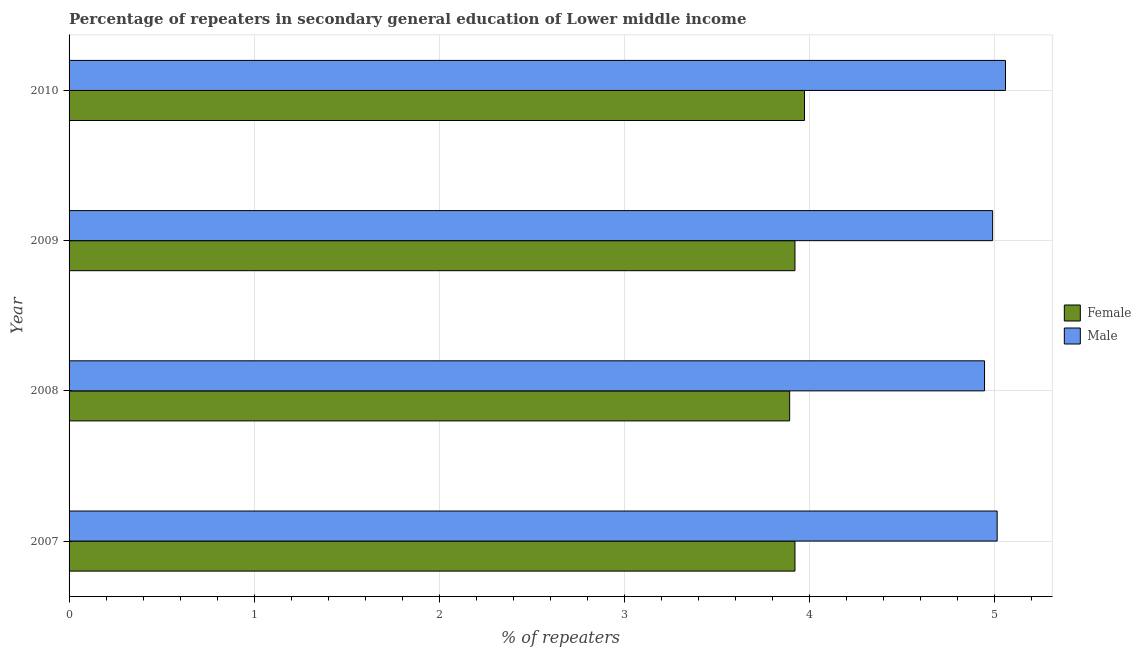Are the number of bars per tick equal to the number of legend labels?
Your answer should be very brief. Yes. How many bars are there on the 3rd tick from the bottom?
Offer a very short reply. 2. What is the percentage of male repeaters in 2007?
Give a very brief answer. 5.01. Across all years, what is the maximum percentage of female repeaters?
Give a very brief answer. 3.97. Across all years, what is the minimum percentage of female repeaters?
Give a very brief answer. 3.89. In which year was the percentage of female repeaters maximum?
Your answer should be compact. 2010. In which year was the percentage of male repeaters minimum?
Your answer should be very brief. 2008. What is the total percentage of male repeaters in the graph?
Offer a terse response. 20. What is the difference between the percentage of male repeaters in 2008 and that in 2010?
Your answer should be compact. -0.11. What is the difference between the percentage of female repeaters in 2008 and the percentage of male repeaters in 2007?
Provide a short and direct response. -1.12. What is the average percentage of female repeaters per year?
Keep it short and to the point. 3.93. In the year 2010, what is the difference between the percentage of female repeaters and percentage of male repeaters?
Offer a very short reply. -1.09. Is the difference between the percentage of male repeaters in 2007 and 2009 greater than the difference between the percentage of female repeaters in 2007 and 2009?
Your answer should be compact. Yes. What is the difference between the highest and the second highest percentage of female repeaters?
Provide a succinct answer. 0.05. What is the difference between the highest and the lowest percentage of male repeaters?
Your answer should be compact. 0.11. What does the 2nd bar from the top in 2010 represents?
Your response must be concise. Female. What does the 1st bar from the bottom in 2008 represents?
Your response must be concise. Female. Are all the bars in the graph horizontal?
Offer a very short reply. Yes. How many years are there in the graph?
Offer a terse response. 4. Does the graph contain grids?
Provide a succinct answer. Yes. Where does the legend appear in the graph?
Provide a short and direct response. Center right. What is the title of the graph?
Keep it short and to the point. Percentage of repeaters in secondary general education of Lower middle income. What is the label or title of the X-axis?
Your response must be concise. % of repeaters. What is the label or title of the Y-axis?
Offer a very short reply. Year. What is the % of repeaters of Female in 2007?
Your answer should be very brief. 3.92. What is the % of repeaters of Male in 2007?
Your response must be concise. 5.01. What is the % of repeaters of Female in 2008?
Offer a very short reply. 3.89. What is the % of repeaters in Male in 2008?
Offer a terse response. 4.94. What is the % of repeaters in Female in 2009?
Keep it short and to the point. 3.92. What is the % of repeaters of Male in 2009?
Provide a short and direct response. 4.99. What is the % of repeaters of Female in 2010?
Keep it short and to the point. 3.97. What is the % of repeaters in Male in 2010?
Ensure brevity in your answer.  5.06. Across all years, what is the maximum % of repeaters of Female?
Your answer should be compact. 3.97. Across all years, what is the maximum % of repeaters in Male?
Make the answer very short. 5.06. Across all years, what is the minimum % of repeaters in Female?
Your response must be concise. 3.89. Across all years, what is the minimum % of repeaters in Male?
Your answer should be very brief. 4.94. What is the total % of repeaters of Female in the graph?
Keep it short and to the point. 15.71. What is the total % of repeaters of Male in the graph?
Ensure brevity in your answer.  20. What is the difference between the % of repeaters of Female in 2007 and that in 2008?
Give a very brief answer. 0.03. What is the difference between the % of repeaters in Male in 2007 and that in 2008?
Provide a short and direct response. 0.07. What is the difference between the % of repeaters of Male in 2007 and that in 2009?
Offer a terse response. 0.02. What is the difference between the % of repeaters of Female in 2007 and that in 2010?
Ensure brevity in your answer.  -0.05. What is the difference between the % of repeaters in Male in 2007 and that in 2010?
Your answer should be compact. -0.04. What is the difference between the % of repeaters of Female in 2008 and that in 2009?
Give a very brief answer. -0.03. What is the difference between the % of repeaters in Male in 2008 and that in 2009?
Provide a short and direct response. -0.04. What is the difference between the % of repeaters in Female in 2008 and that in 2010?
Provide a succinct answer. -0.08. What is the difference between the % of repeaters of Male in 2008 and that in 2010?
Provide a short and direct response. -0.11. What is the difference between the % of repeaters in Female in 2009 and that in 2010?
Your answer should be very brief. -0.05. What is the difference between the % of repeaters of Male in 2009 and that in 2010?
Your answer should be very brief. -0.07. What is the difference between the % of repeaters in Female in 2007 and the % of repeaters in Male in 2008?
Your response must be concise. -1.02. What is the difference between the % of repeaters in Female in 2007 and the % of repeaters in Male in 2009?
Provide a succinct answer. -1.07. What is the difference between the % of repeaters in Female in 2007 and the % of repeaters in Male in 2010?
Your response must be concise. -1.14. What is the difference between the % of repeaters in Female in 2008 and the % of repeaters in Male in 2009?
Provide a succinct answer. -1.1. What is the difference between the % of repeaters of Female in 2008 and the % of repeaters of Male in 2010?
Give a very brief answer. -1.17. What is the difference between the % of repeaters of Female in 2009 and the % of repeaters of Male in 2010?
Your answer should be very brief. -1.14. What is the average % of repeaters in Female per year?
Make the answer very short. 3.93. What is the average % of repeaters in Male per year?
Offer a terse response. 5. In the year 2007, what is the difference between the % of repeaters of Female and % of repeaters of Male?
Offer a terse response. -1.09. In the year 2008, what is the difference between the % of repeaters in Female and % of repeaters in Male?
Offer a terse response. -1.05. In the year 2009, what is the difference between the % of repeaters in Female and % of repeaters in Male?
Provide a succinct answer. -1.07. In the year 2010, what is the difference between the % of repeaters of Female and % of repeaters of Male?
Provide a succinct answer. -1.09. What is the ratio of the % of repeaters of Female in 2007 to that in 2008?
Your answer should be very brief. 1.01. What is the ratio of the % of repeaters in Male in 2007 to that in 2008?
Make the answer very short. 1.01. What is the ratio of the % of repeaters in Female in 2007 to that in 2010?
Provide a succinct answer. 0.99. What is the ratio of the % of repeaters in Male in 2007 to that in 2010?
Your answer should be very brief. 0.99. What is the ratio of the % of repeaters of Female in 2008 to that in 2010?
Provide a succinct answer. 0.98. What is the ratio of the % of repeaters of Male in 2008 to that in 2010?
Your answer should be very brief. 0.98. What is the ratio of the % of repeaters in Female in 2009 to that in 2010?
Ensure brevity in your answer.  0.99. What is the ratio of the % of repeaters of Male in 2009 to that in 2010?
Ensure brevity in your answer.  0.99. What is the difference between the highest and the second highest % of repeaters of Female?
Your response must be concise. 0.05. What is the difference between the highest and the second highest % of repeaters in Male?
Ensure brevity in your answer.  0.04. What is the difference between the highest and the lowest % of repeaters of Female?
Your answer should be very brief. 0.08. What is the difference between the highest and the lowest % of repeaters in Male?
Make the answer very short. 0.11. 